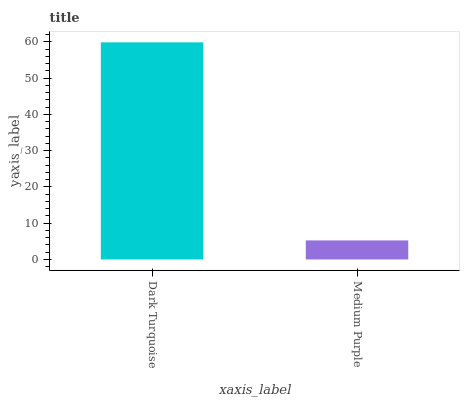Is Medium Purple the minimum?
Answer yes or no. Yes. Is Dark Turquoise the maximum?
Answer yes or no. Yes. Is Medium Purple the maximum?
Answer yes or no. No. Is Dark Turquoise greater than Medium Purple?
Answer yes or no. Yes. Is Medium Purple less than Dark Turquoise?
Answer yes or no. Yes. Is Medium Purple greater than Dark Turquoise?
Answer yes or no. No. Is Dark Turquoise less than Medium Purple?
Answer yes or no. No. Is Dark Turquoise the high median?
Answer yes or no. Yes. Is Medium Purple the low median?
Answer yes or no. Yes. Is Medium Purple the high median?
Answer yes or no. No. Is Dark Turquoise the low median?
Answer yes or no. No. 